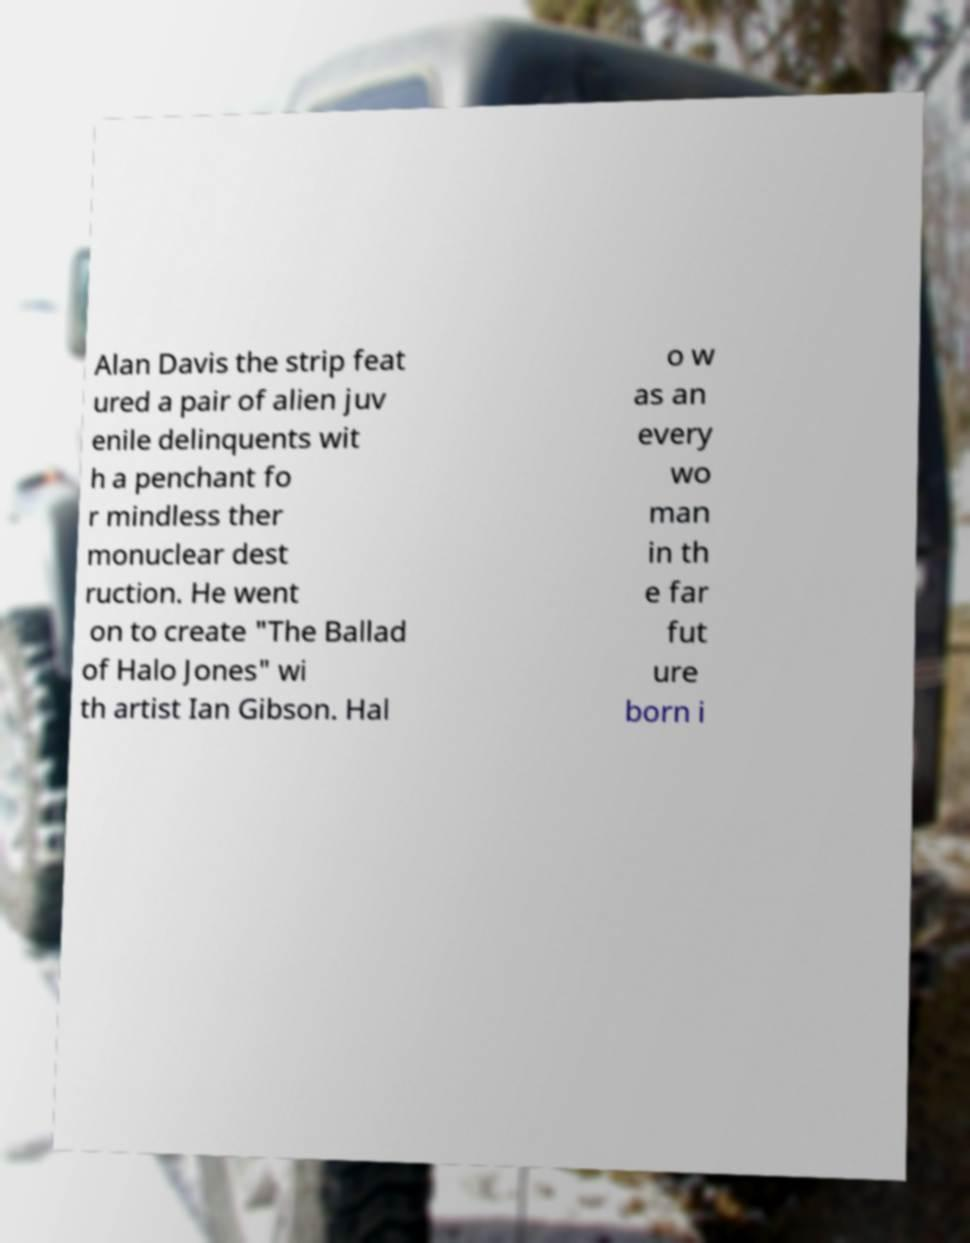For documentation purposes, I need the text within this image transcribed. Could you provide that? Alan Davis the strip feat ured a pair of alien juv enile delinquents wit h a penchant fo r mindless ther monuclear dest ruction. He went on to create "The Ballad of Halo Jones" wi th artist Ian Gibson. Hal o w as an every wo man in th e far fut ure born i 